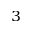Convert formula to latex. <formula><loc_0><loc_0><loc_500><loc_500>_ { 3 }</formula> 